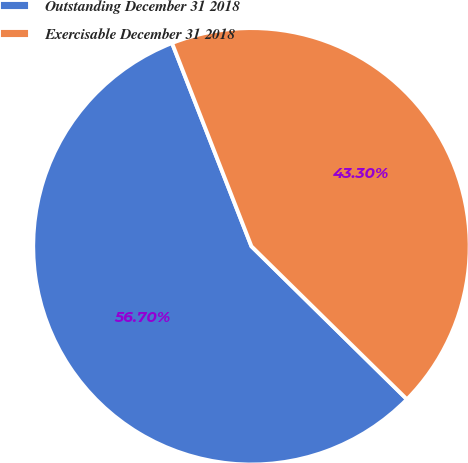Convert chart. <chart><loc_0><loc_0><loc_500><loc_500><pie_chart><fcel>Outstanding December 31 2018<fcel>Exercisable December 31 2018<nl><fcel>56.7%<fcel>43.3%<nl></chart> 